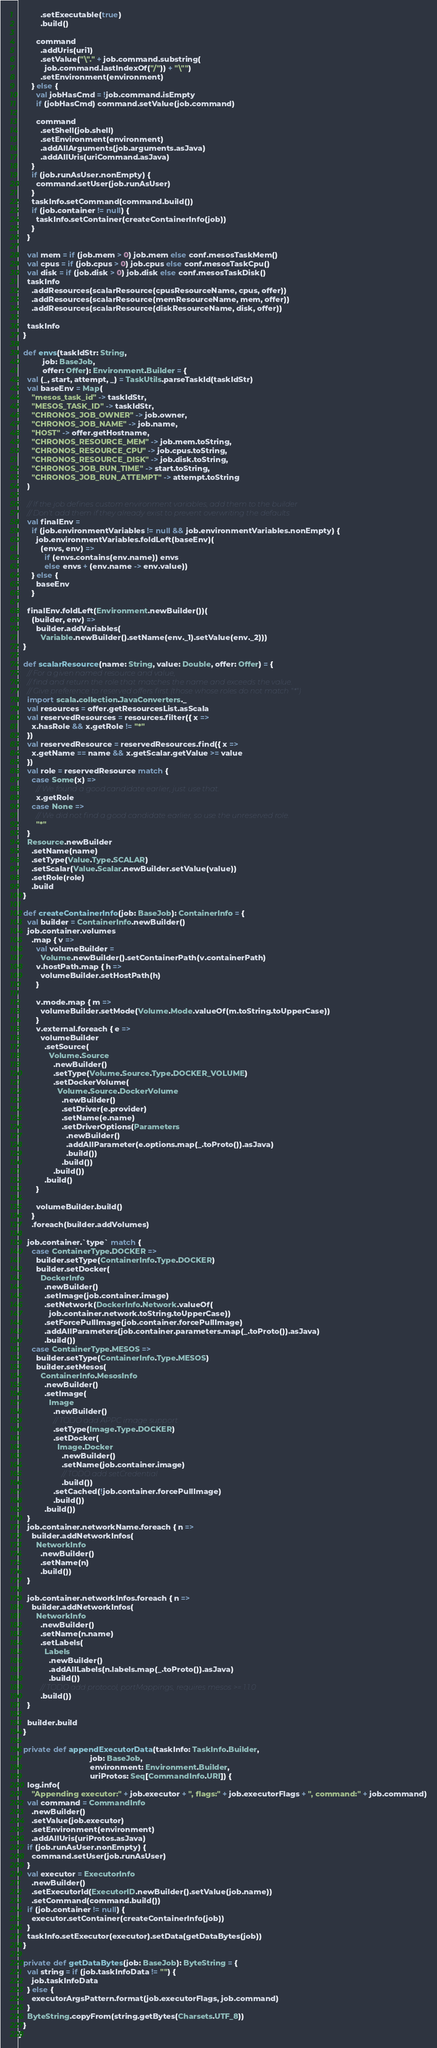Convert code to text. <code><loc_0><loc_0><loc_500><loc_500><_Scala_>          .setExecutable(true)
          .build()

        command
          .addUris(uri1)
          .setValue("\"." + job.command.substring(
            job.command.lastIndexOf("/")) + "\"")
          .setEnvironment(environment)
      } else {
        val jobHasCmd = !job.command.isEmpty
        if (jobHasCmd) command.setValue(job.command)

        command
          .setShell(job.shell)
          .setEnvironment(environment)
          .addAllArguments(job.arguments.asJava)
          .addAllUris(uriCommand.asJava)
      }
      if (job.runAsUser.nonEmpty) {
        command.setUser(job.runAsUser)
      }
      taskInfo.setCommand(command.build())
      if (job.container != null) {
        taskInfo.setContainer(createContainerInfo(job))
      }
    }

    val mem = if (job.mem > 0) job.mem else conf.mesosTaskMem()
    val cpus = if (job.cpus > 0) job.cpus else conf.mesosTaskCpu()
    val disk = if (job.disk > 0) job.disk else conf.mesosTaskDisk()
    taskInfo
      .addResources(scalarResource(cpusResourceName, cpus, offer))
      .addResources(scalarResource(memResourceName, mem, offer))
      .addResources(scalarResource(diskResourceName, disk, offer))

    taskInfo
  }

  def envs(taskIdStr: String,
           job: BaseJob,
           offer: Offer): Environment.Builder = {
    val (_, start, attempt, _) = TaskUtils.parseTaskId(taskIdStr)
    val baseEnv = Map(
      "mesos_task_id" -> taskIdStr,
      "MESOS_TASK_ID" -> taskIdStr,
      "CHRONOS_JOB_OWNER" -> job.owner,
      "CHRONOS_JOB_NAME" -> job.name,
      "HOST" -> offer.getHostname,
      "CHRONOS_RESOURCE_MEM" -> job.mem.toString,
      "CHRONOS_RESOURCE_CPU" -> job.cpus.toString,
      "CHRONOS_RESOURCE_DISK" -> job.disk.toString,
      "CHRONOS_JOB_RUN_TIME" -> start.toString,
      "CHRONOS_JOB_RUN_ATTEMPT" -> attempt.toString
    )

    // If the job defines custom environment variables, add them to the builder
    // Don't add them if they already exist to prevent overwriting the defaults
    val finalEnv =
      if (job.environmentVariables != null && job.environmentVariables.nonEmpty) {
        job.environmentVariables.foldLeft(baseEnv)(
          (envs, env) =>
            if (envs.contains(env.name)) envs
            else envs + (env.name -> env.value))
      } else {
        baseEnv
      }

    finalEnv.foldLeft(Environment.newBuilder())(
      (builder, env) =>
        builder.addVariables(
          Variable.newBuilder().setName(env._1).setValue(env._2)))
  }

  def scalarResource(name: String, value: Double, offer: Offer) = {
    // For a given named resource and value,
    // find and return the role that matches the name and exceeds the value.
    // Give preference to reserved offers first (those whose roles do not match "*")
    import scala.collection.JavaConverters._
    val resources = offer.getResourcesList.asScala
    val reservedResources = resources.filter({ x =>
      x.hasRole && x.getRole != "*"
    })
    val reservedResource = reservedResources.find({ x =>
      x.getName == name && x.getScalar.getValue >= value
    })
    val role = reservedResource match {
      case Some(x) =>
        // We found a good candidate earlier, just use that.
        x.getRole
      case None =>
        // We did not find a good candidate earlier, so use the unreserved role.
        "*"
    }
    Resource.newBuilder
      .setName(name)
      .setType(Value.Type.SCALAR)
      .setScalar(Value.Scalar.newBuilder.setValue(value))
      .setRole(role)
      .build
  }

  def createContainerInfo(job: BaseJob): ContainerInfo = {
    val builder = ContainerInfo.newBuilder()
    job.container.volumes
      .map { v =>
        val volumeBuilder =
          Volume.newBuilder().setContainerPath(v.containerPath)
        v.hostPath.map { h =>
          volumeBuilder.setHostPath(h)
        }

        v.mode.map { m =>
          volumeBuilder.setMode(Volume.Mode.valueOf(m.toString.toUpperCase))
        }
        v.external.foreach { e =>
          volumeBuilder
            .setSource(
              Volume.Source
                .newBuilder()
                .setType(Volume.Source.Type.DOCKER_VOLUME)
                .setDockerVolume(
                  Volume.Source.DockerVolume
                    .newBuilder()
                    .setDriver(e.provider)
                    .setName(e.name)
                    .setDriverOptions(Parameters
                      .newBuilder()
                      .addAllParameter(e.options.map(_.toProto()).asJava)
                      .build())
                    .build())
                .build())
            .build()
        }

        volumeBuilder.build()
      }
      .foreach(builder.addVolumes)

    job.container.`type` match {
      case ContainerType.DOCKER =>
        builder.setType(ContainerInfo.Type.DOCKER)
        builder.setDocker(
          DockerInfo
            .newBuilder()
            .setImage(job.container.image)
            .setNetwork(DockerInfo.Network.valueOf(
              job.container.network.toString.toUpperCase))
            .setForcePullImage(job.container.forcePullImage)
            .addAllParameters(job.container.parameters.map(_.toProto()).asJava)
            .build())
      case ContainerType.MESOS =>
        builder.setType(ContainerInfo.Type.MESOS)
        builder.setMesos(
          ContainerInfo.MesosInfo
            .newBuilder()
            .setImage(
              Image
                .newBuilder()
                // TODO add APPC image support
                .setType(Image.Type.DOCKER)
                .setDocker(
                  Image.Docker
                    .newBuilder()
                    .setName(job.container.image)
                    // TODO add setCredential
                    .build())
                .setCached(!job.container.forcePullImage)
                .build())
            .build())
    }
    job.container.networkName.foreach { n =>
      builder.addNetworkInfos(
        NetworkInfo
          .newBuilder()
          .setName(n)
          .build())
    }

    job.container.networkInfos.foreach { n =>
      builder.addNetworkInfos(
        NetworkInfo
          .newBuilder()
          .setName(n.name)
          .setLabels(
            Labels
              .newBuilder()
              .addAllLabels(n.labels.map(_.toProto()).asJava)
              .build())
          // TODO add protocol, portMappings, requires mesos >= 1.1.0
          .build())
    }

    builder.build
  }

  private def appendExecutorData(taskInfo: TaskInfo.Builder,
                                 job: BaseJob,
                                 environment: Environment.Builder,
                                 uriProtos: Seq[CommandInfo.URI]) {
    log.info(
      "Appending executor:" + job.executor + ", flags:" + job.executorFlags + ", command:" + job.command)
    val command = CommandInfo
      .newBuilder()
      .setValue(job.executor)
      .setEnvironment(environment)
      .addAllUris(uriProtos.asJava)
    if (job.runAsUser.nonEmpty) {
      command.setUser(job.runAsUser)
    }
    val executor = ExecutorInfo
      .newBuilder()
      .setExecutorId(ExecutorID.newBuilder().setValue(job.name))
      .setCommand(command.build())
    if (job.container != null) {
      executor.setContainer(createContainerInfo(job))
    }
    taskInfo.setExecutor(executor).setData(getDataBytes(job))
  }

  private def getDataBytes(job: BaseJob): ByteString = {
    val string = if (job.taskInfoData != "") {
      job.taskInfoData
    } else {
      executorArgsPattern.format(job.executorFlags, job.command)
    }
    ByteString.copyFrom(string.getBytes(Charsets.UTF_8))
  }
}
</code> 